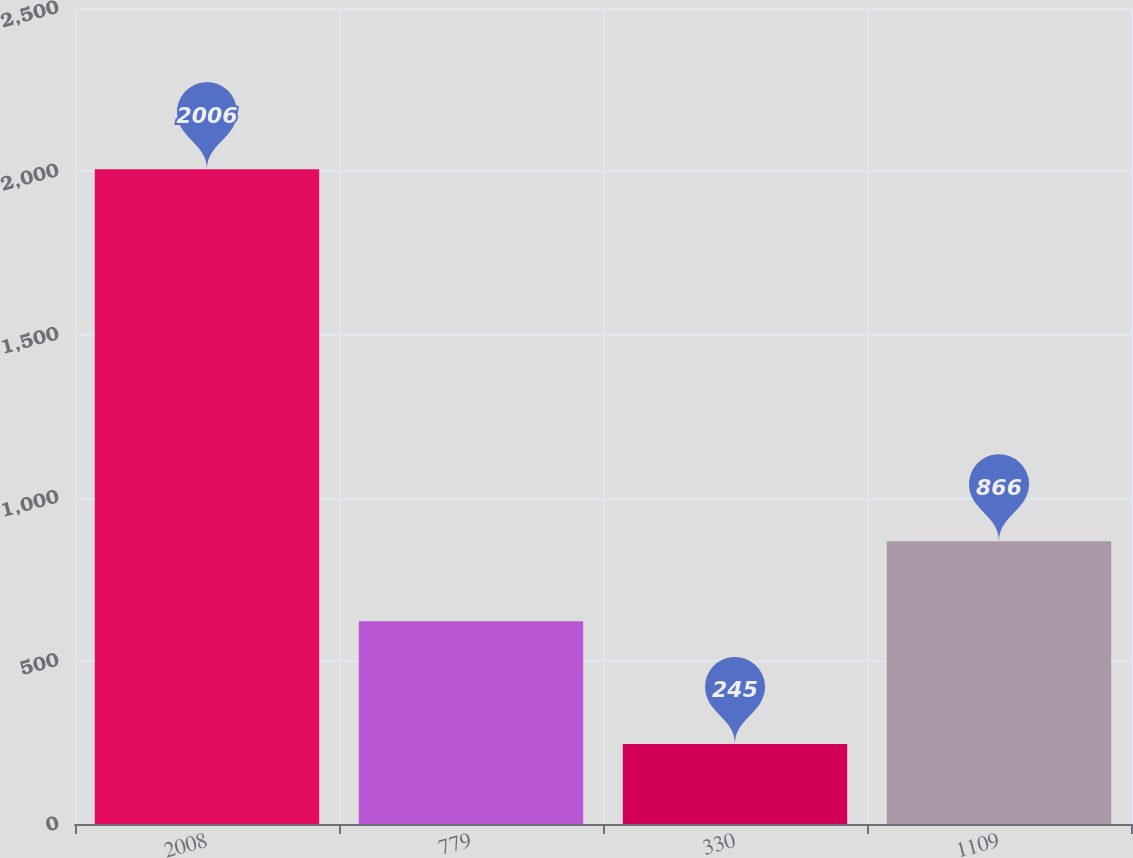<chart> <loc_0><loc_0><loc_500><loc_500><bar_chart><fcel>2008<fcel>779<fcel>330<fcel>1109<nl><fcel>2006<fcel>621<fcel>245<fcel>866<nl></chart> 